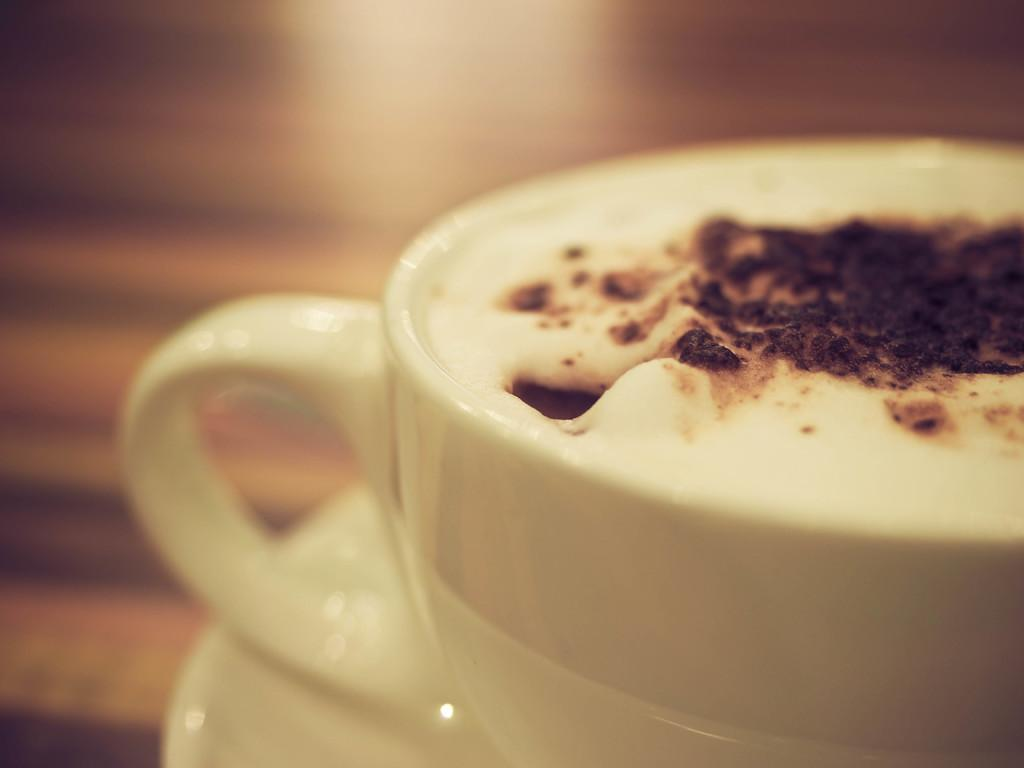What is in the cup that is visible in the image? There is coffee in a cup in the image. What type of brush is being used to paint the market in the image? There is no brush, market, or painting present in the image; it only features a cup of coffee. 